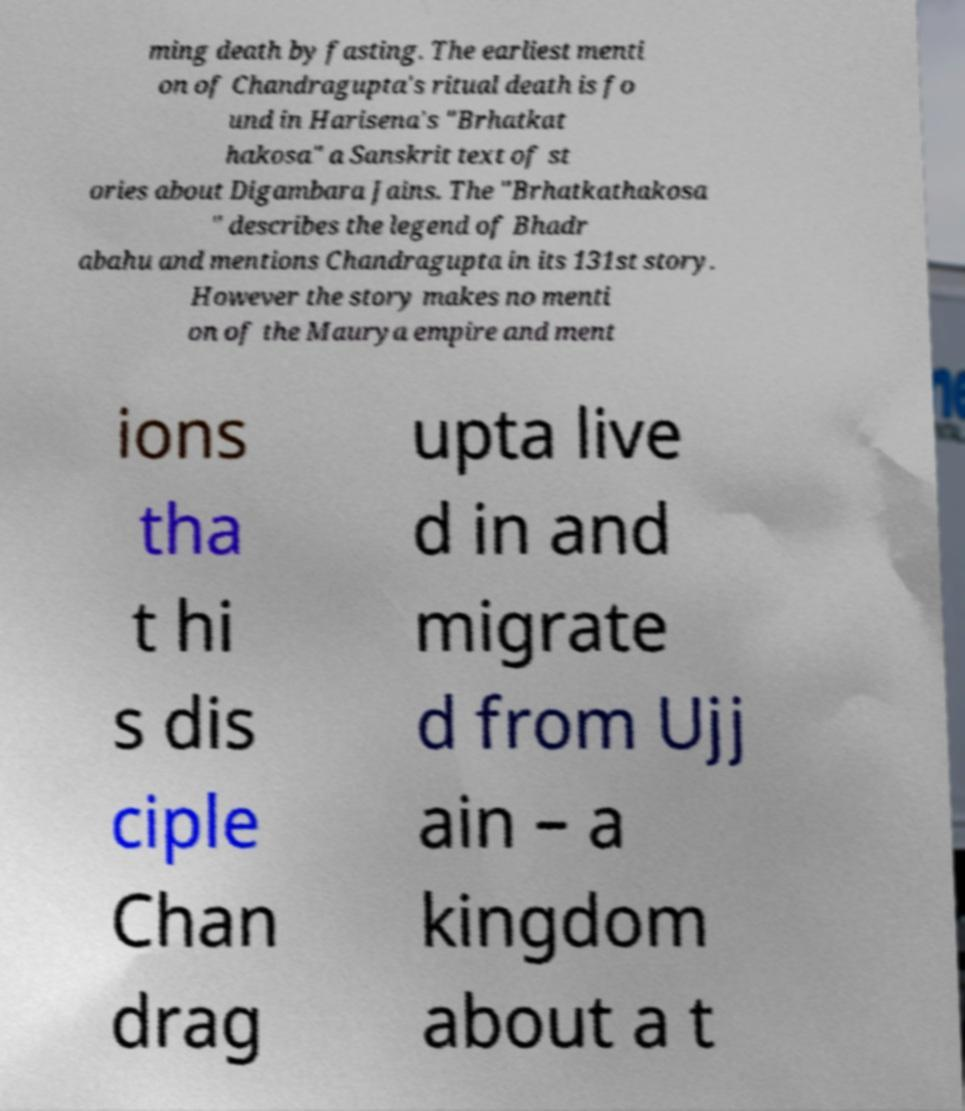There's text embedded in this image that I need extracted. Can you transcribe it verbatim? ming death by fasting. The earliest menti on of Chandragupta's ritual death is fo und in Harisena's "Brhatkat hakosa" a Sanskrit text of st ories about Digambara Jains. The "Brhatkathakosa " describes the legend of Bhadr abahu and mentions Chandragupta in its 131st story. However the story makes no menti on of the Maurya empire and ment ions tha t hi s dis ciple Chan drag upta live d in and migrate d from Ujj ain – a kingdom about a t 